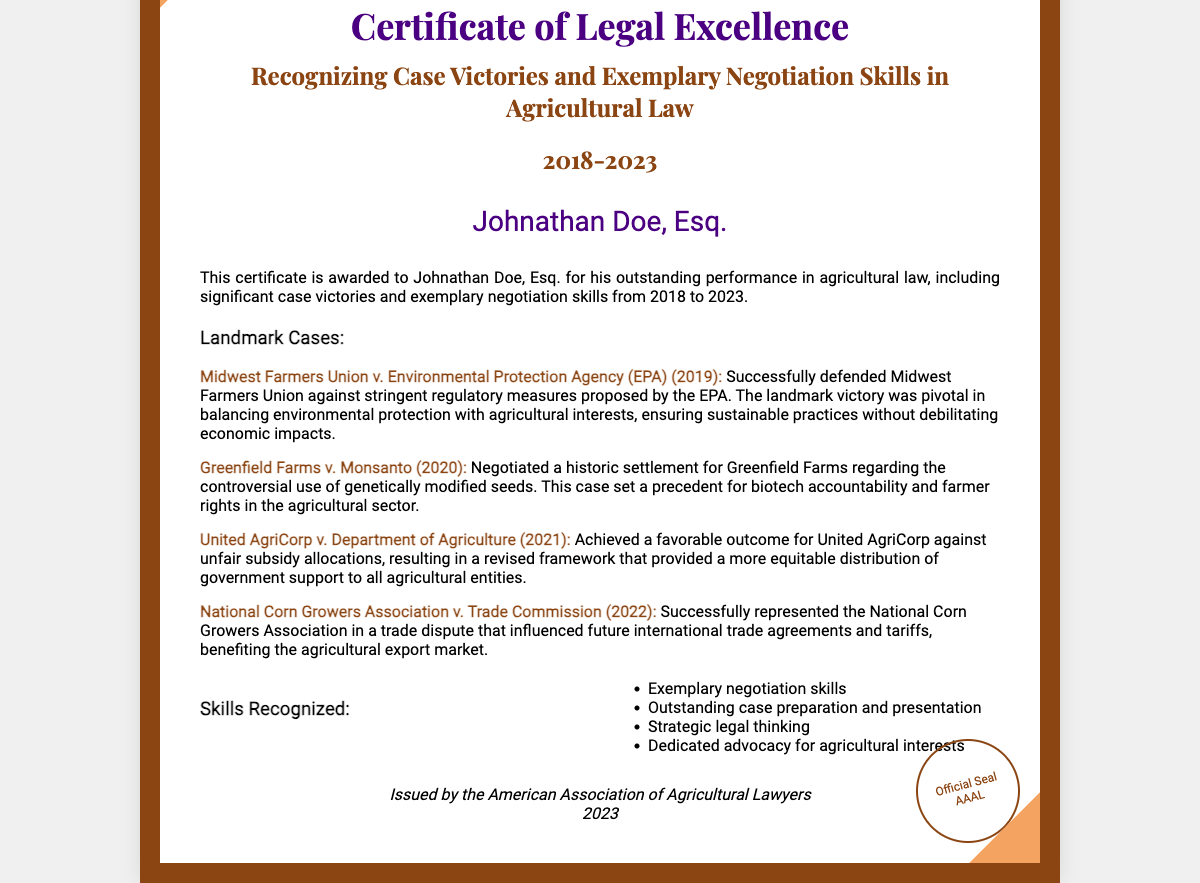What is the name of the attorney recognized in the certificate? The attorney recognized in the certificate is Johnathan Doe, Esq.
Answer: Johnathan Doe, Esq What years does the certificate cover? The certificate recognizes achievements from 2018 to 2023.
Answer: 2018-2023 What was the outcome of Midwest Farmers Union v. Environmental Protection Agency? The outcome was a successful defense against regulatory measures proposed by the EPA.
Answer: Successful defense Which case involved a settlement regarding genetically modified seeds? The case involving a settlement regarding genetically modified seeds is Greenfield Farms v. Monsanto.
Answer: Greenfield Farms v. Monsanto Which organization issued the certificate? The organization that issued the certificate is the American Association of Agricultural Lawyers.
Answer: American Association of Agricultural Lawyers What skill related to legal work is specifically mentioned in the document? Exemplary negotiation skills are mentioned as one of the recognized skills.
Answer: Exemplary negotiation skills What is the landmark case that influenced international trade agreements? The landmark case is National Corn Growers Association v. Trade Commission.
Answer: National Corn Growers Association v. Trade Commission In which year was the case United AgriCorp v. Department of Agriculture decided? The case was decided in 2021.
Answer: 2021 